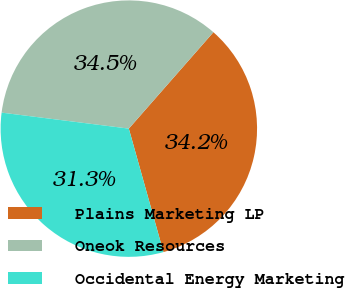Convert chart. <chart><loc_0><loc_0><loc_500><loc_500><pie_chart><fcel>Plains Marketing LP<fcel>Oneok Resources<fcel>Occidental Energy Marketing<nl><fcel>34.19%<fcel>34.47%<fcel>31.34%<nl></chart> 